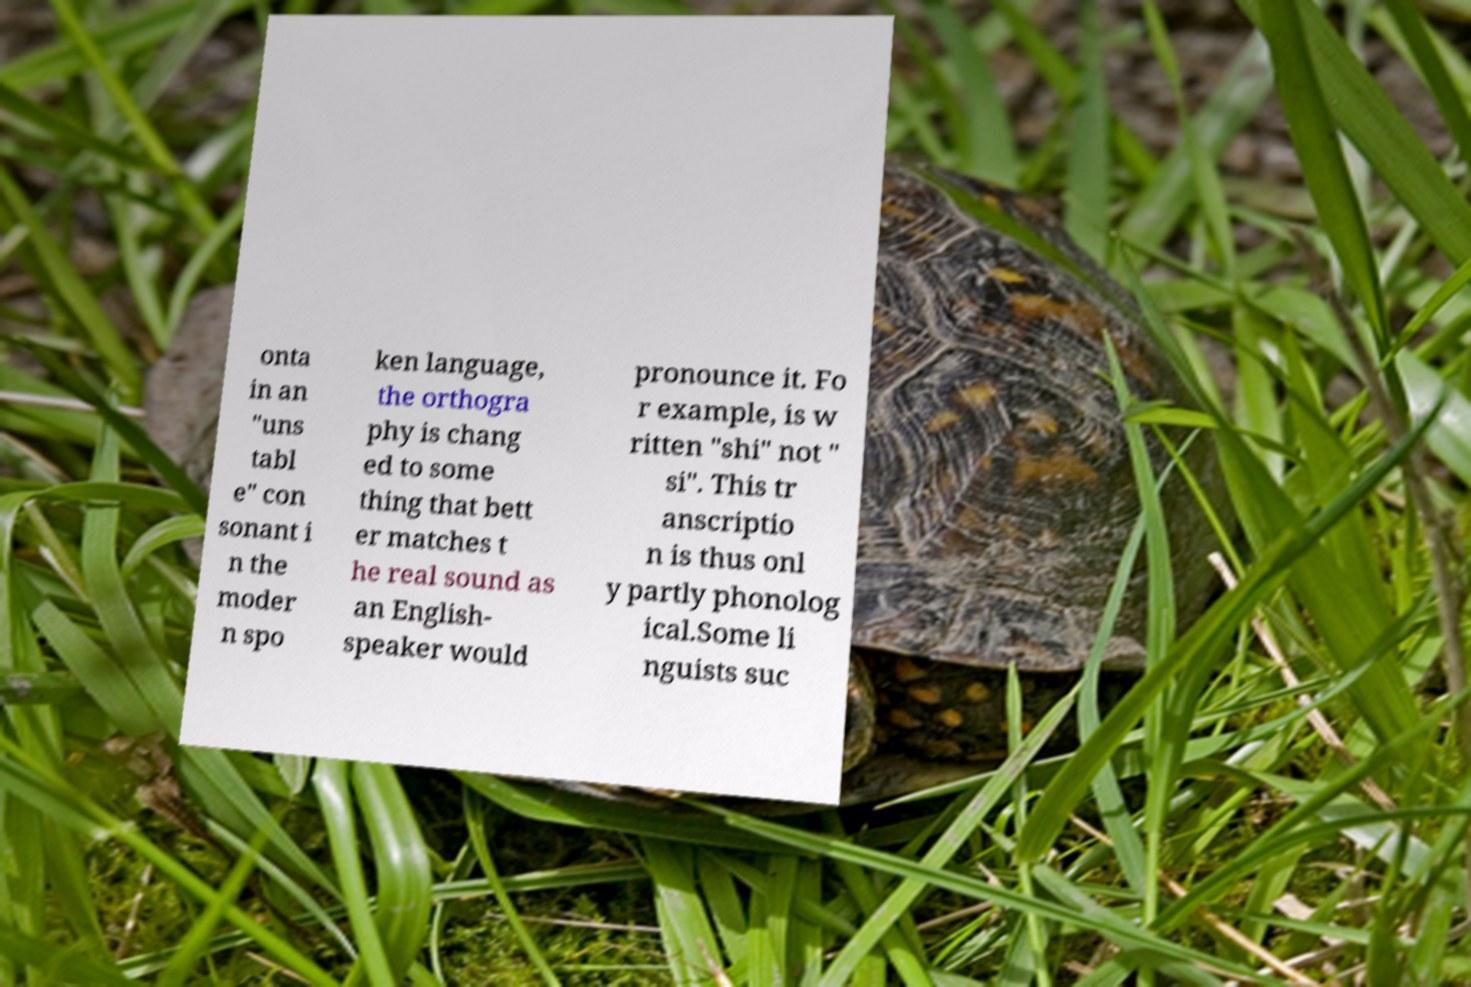Please read and relay the text visible in this image. What does it say? onta in an "uns tabl e" con sonant i n the moder n spo ken language, the orthogra phy is chang ed to some thing that bett er matches t he real sound as an English- speaker would pronounce it. Fo r example, is w ritten "shi" not " si". This tr anscriptio n is thus onl y partly phonolog ical.Some li nguists suc 